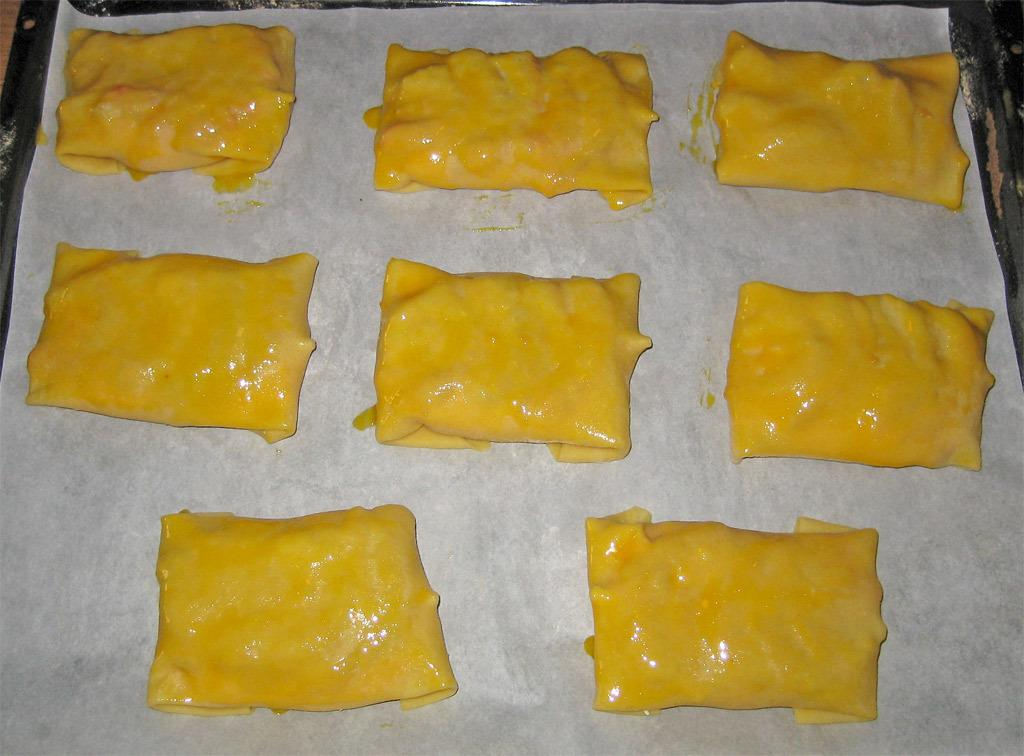What type of objects can be seen in the image? There are food items in the image. On what surface are the food items placed? The food items are present on a white color paper. What type of town is being discussed in the image? There is no town present in the image, as it only features food items on a white color paper. 